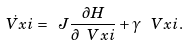Convert formula to latex. <formula><loc_0><loc_0><loc_500><loc_500>\dot { \ V x i } = \ J \frac { \partial H } { \partial \ V x i } + \gamma \, \ V x i .</formula> 